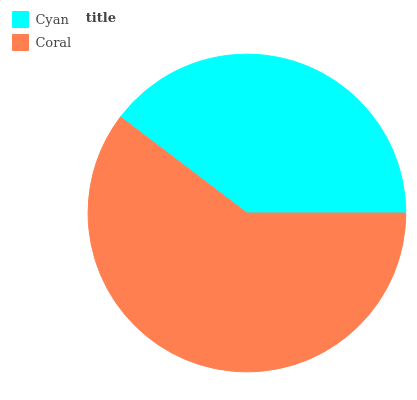Is Cyan the minimum?
Answer yes or no. Yes. Is Coral the maximum?
Answer yes or no. Yes. Is Coral the minimum?
Answer yes or no. No. Is Coral greater than Cyan?
Answer yes or no. Yes. Is Cyan less than Coral?
Answer yes or no. Yes. Is Cyan greater than Coral?
Answer yes or no. No. Is Coral less than Cyan?
Answer yes or no. No. Is Coral the high median?
Answer yes or no. Yes. Is Cyan the low median?
Answer yes or no. Yes. Is Cyan the high median?
Answer yes or no. No. Is Coral the low median?
Answer yes or no. No. 